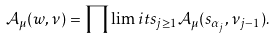<formula> <loc_0><loc_0><loc_500><loc_500>\mathcal { A } _ { \mu } ( w , \nu ) = \prod \lim i t s _ { j \geq 1 } \mathcal { A } _ { \mu } ( s _ { \alpha _ { j } } , \nu _ { j - 1 } ) .</formula> 